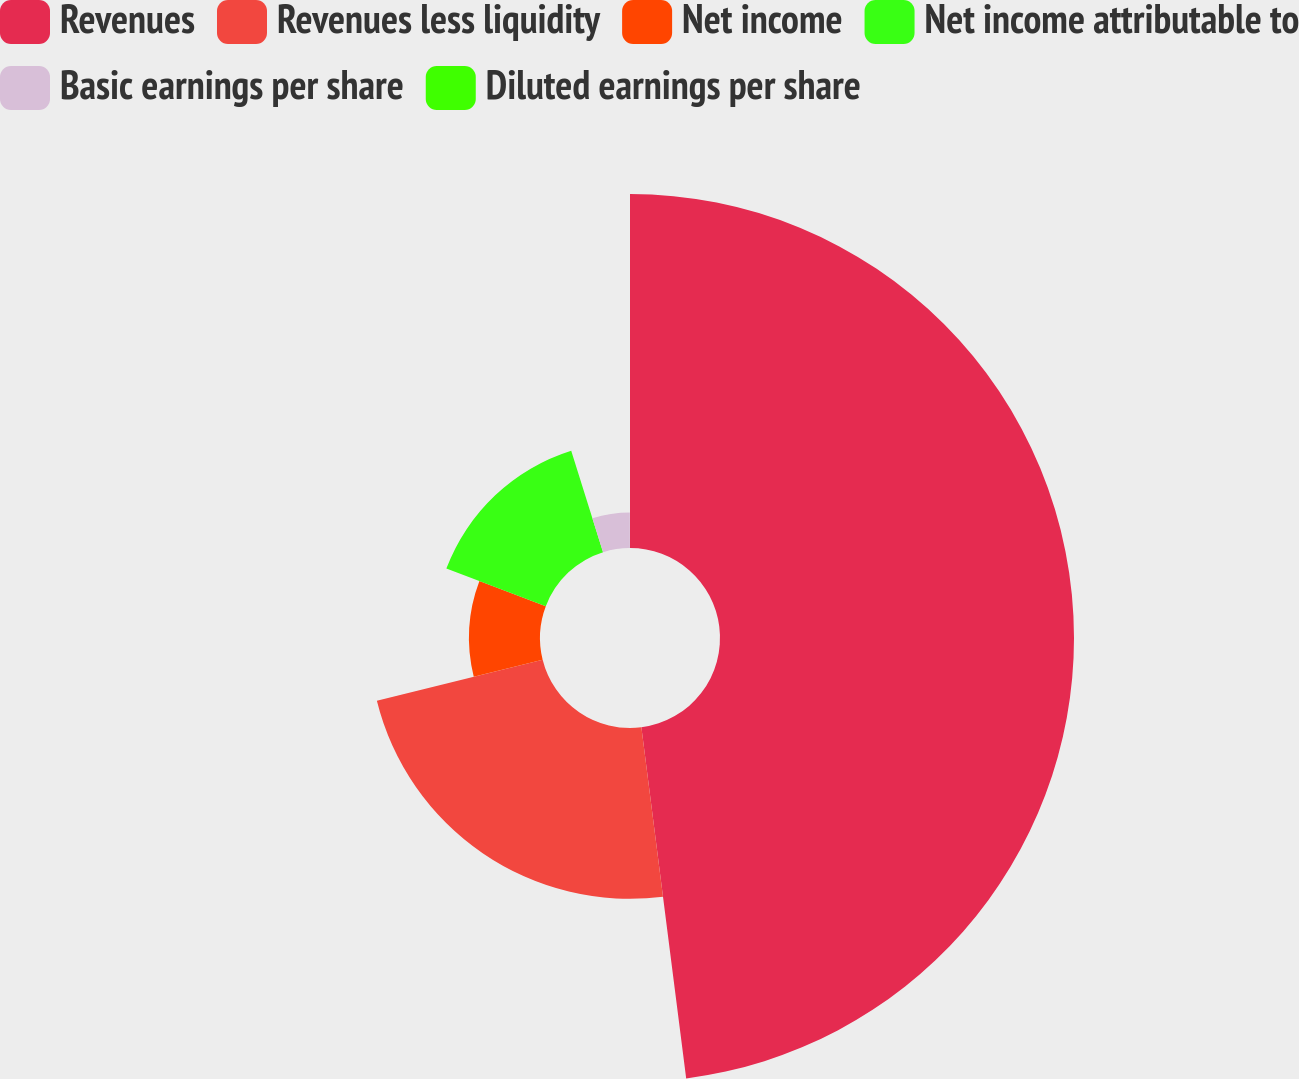Convert chart to OTSL. <chart><loc_0><loc_0><loc_500><loc_500><pie_chart><fcel>Revenues<fcel>Revenues less liquidity<fcel>Net income<fcel>Net income attributable to<fcel>Basic earnings per share<fcel>Diluted earnings per share<nl><fcel>47.98%<fcel>23.15%<fcel>9.62%<fcel>14.41%<fcel>4.82%<fcel>0.02%<nl></chart> 